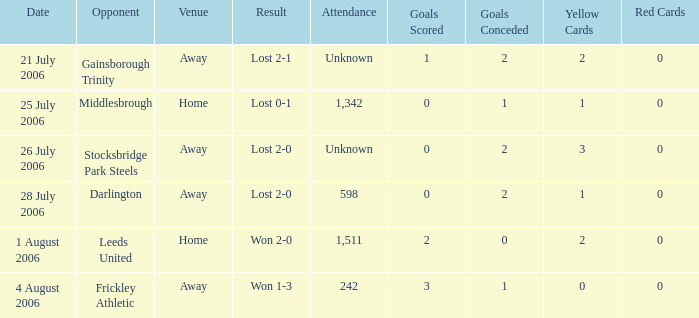What is the result from the Leeds United opponent? Won 2-0. 